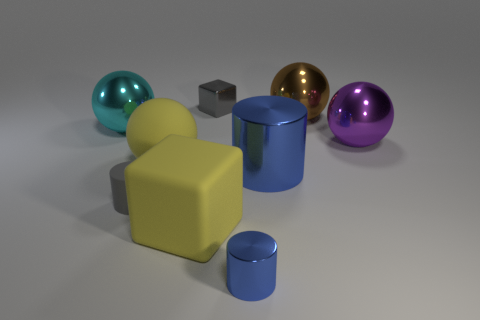Can you describe the size differences among the objects in the image? Certainly! In the image, there is a variety of objects ranging in size. The blue cylinder and the yellow sphere are the largest visible objects, while the smallest appear to be the gray cube and the smaller blue cylinder. Are there any textures present on these objects? Yes, the objects display various textures. The spheres and the large cylinder have smooth, reflective surfaces, indicative of a metallic texture, whereas the yellow cube and the smaller cylinder exhibit a matte texture that does not reflect light. 